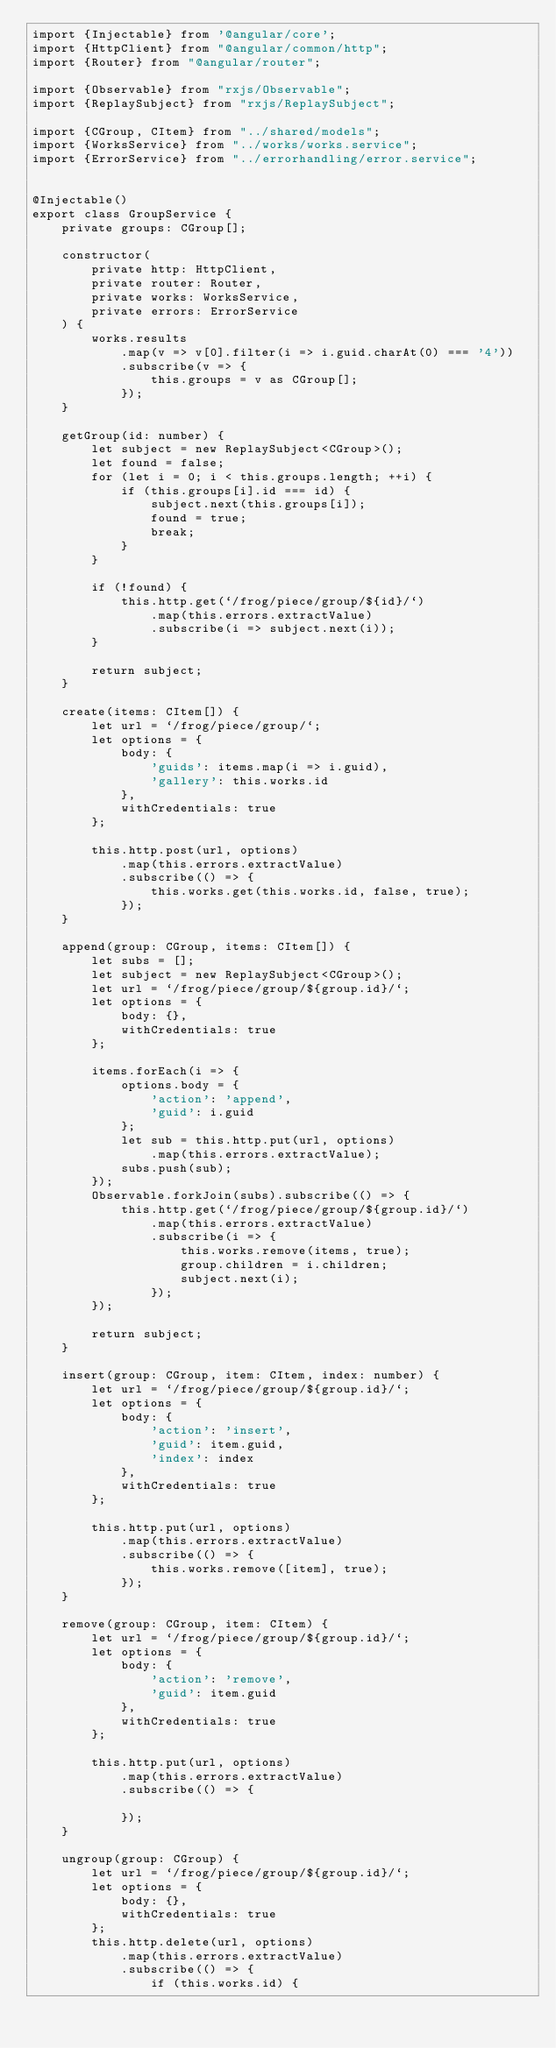<code> <loc_0><loc_0><loc_500><loc_500><_TypeScript_>import {Injectable} from '@angular/core';
import {HttpClient} from "@angular/common/http";
import {Router} from "@angular/router";

import {Observable} from "rxjs/Observable";
import {ReplaySubject} from "rxjs/ReplaySubject";

import {CGroup, CItem} from "../shared/models";
import {WorksService} from "../works/works.service";
import {ErrorService} from "../errorhandling/error.service";


@Injectable()
export class GroupService {
    private groups: CGroup[];

    constructor(
        private http: HttpClient,
        private router: Router,
        private works: WorksService,
        private errors: ErrorService
    ) {
        works.results
            .map(v => v[0].filter(i => i.guid.charAt(0) === '4'))
            .subscribe(v => {
                this.groups = v as CGroup[];
            });
    }

    getGroup(id: number) {
        let subject = new ReplaySubject<CGroup>();
        let found = false;
        for (let i = 0; i < this.groups.length; ++i) {
            if (this.groups[i].id === id) {
                subject.next(this.groups[i]);
                found = true;
                break;
            }
        }

        if (!found) {
            this.http.get(`/frog/piece/group/${id}/`)
                .map(this.errors.extractValue)
                .subscribe(i => subject.next(i));
        }

        return subject;
    }

    create(items: CItem[]) {
        let url = `/frog/piece/group/`;
        let options = {
            body: {
                'guids': items.map(i => i.guid),
                'gallery': this.works.id
            },
            withCredentials: true
        };

        this.http.post(url, options)
            .map(this.errors.extractValue)
            .subscribe(() => {
                this.works.get(this.works.id, false, true);
            });
    }

    append(group: CGroup, items: CItem[]) {
        let subs = [];
        let subject = new ReplaySubject<CGroup>();
        let url = `/frog/piece/group/${group.id}/`;
        let options = {
            body: {},
            withCredentials: true
        };

        items.forEach(i => {
            options.body = {
                'action': 'append',
                'guid': i.guid
            };
            let sub = this.http.put(url, options)
                .map(this.errors.extractValue);
            subs.push(sub);
        });
        Observable.forkJoin(subs).subscribe(() => {
            this.http.get(`/frog/piece/group/${group.id}/`)
                .map(this.errors.extractValue)
                .subscribe(i => {
                    this.works.remove(items, true);
                    group.children = i.children;
                    subject.next(i);
                });
        });

        return subject;
    }

    insert(group: CGroup, item: CItem, index: number) {
        let url = `/frog/piece/group/${group.id}/`;
        let options = {
            body: {
                'action': 'insert',
                'guid': item.guid,
                'index': index
            },
            withCredentials: true
        };

        this.http.put(url, options)
            .map(this.errors.extractValue)
            .subscribe(() => {
                this.works.remove([item], true);
            });
    }

    remove(group: CGroup, item: CItem) {
        let url = `/frog/piece/group/${group.id}/`;
        let options = {
            body: {
                'action': 'remove',
                'guid': item.guid
            },
            withCredentials: true
        };

        this.http.put(url, options)
            .map(this.errors.extractValue)
            .subscribe(() => {

            });
    }

    ungroup(group: CGroup) {
        let url = `/frog/piece/group/${group.id}/`;
        let options = {
            body: {},
            withCredentials: true
        };
        this.http.delete(url, options)
            .map(this.errors.extractValue)
            .subscribe(() => {
                if (this.works.id) {</code> 